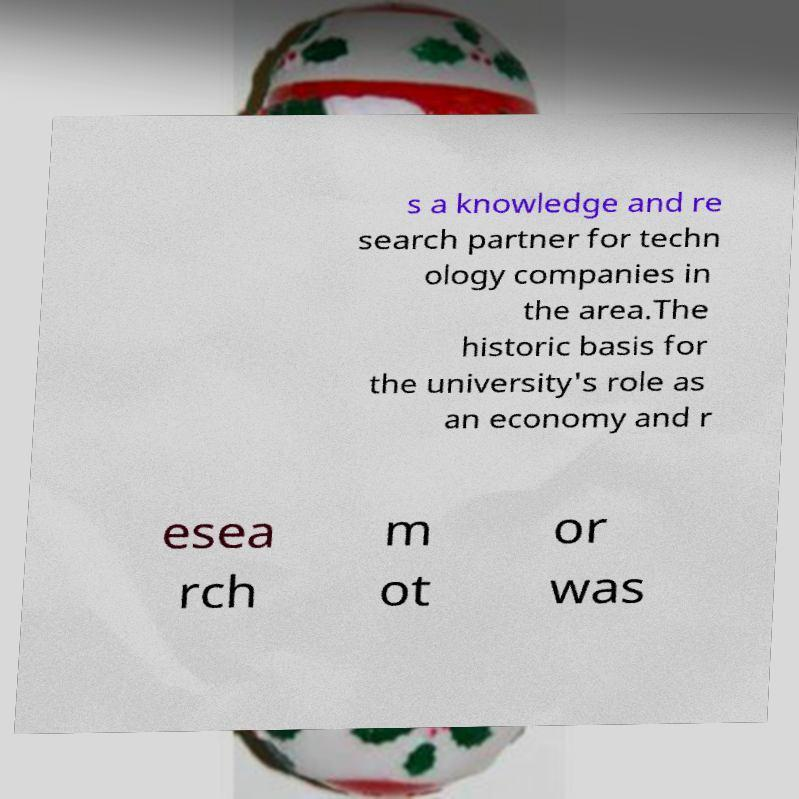For documentation purposes, I need the text within this image transcribed. Could you provide that? s a knowledge and re search partner for techn ology companies in the area.The historic basis for the university's role as an economy and r esea rch m ot or was 